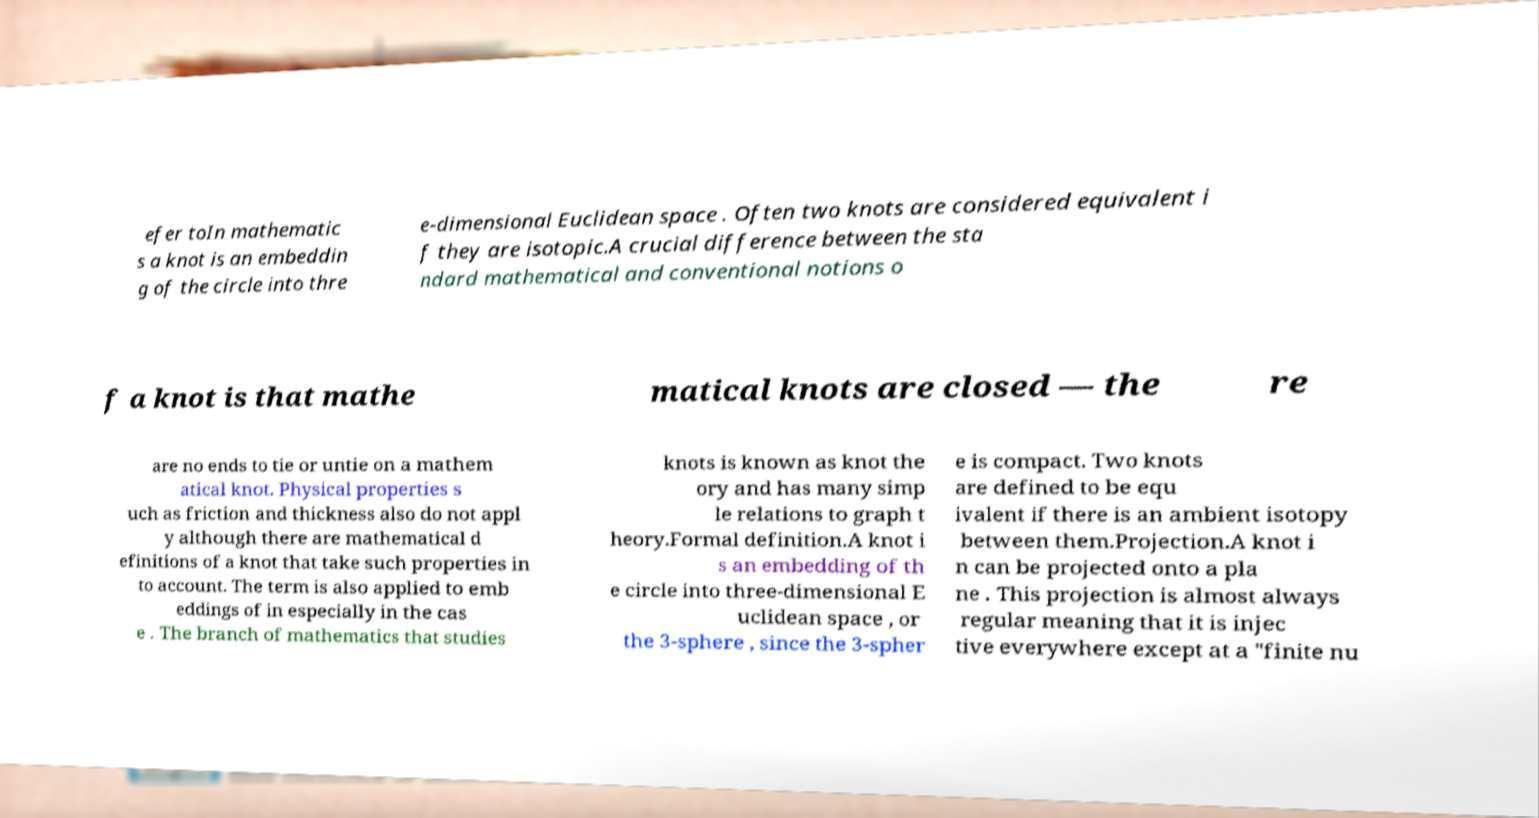Can you read and provide the text displayed in the image?This photo seems to have some interesting text. Can you extract and type it out for me? efer toIn mathematic s a knot is an embeddin g of the circle into thre e-dimensional Euclidean space . Often two knots are considered equivalent i f they are isotopic.A crucial difference between the sta ndard mathematical and conventional notions o f a knot is that mathe matical knots are closed — the re are no ends to tie or untie on a mathem atical knot. Physical properties s uch as friction and thickness also do not appl y although there are mathematical d efinitions of a knot that take such properties in to account. The term is also applied to emb eddings of in especially in the cas e . The branch of mathematics that studies knots is known as knot the ory and has many simp le relations to graph t heory.Formal definition.A knot i s an embedding of th e circle into three-dimensional E uclidean space , or the 3-sphere , since the 3-spher e is compact. Two knots are defined to be equ ivalent if there is an ambient isotopy between them.Projection.A knot i n can be projected onto a pla ne . This projection is almost always regular meaning that it is injec tive everywhere except at a "finite nu 